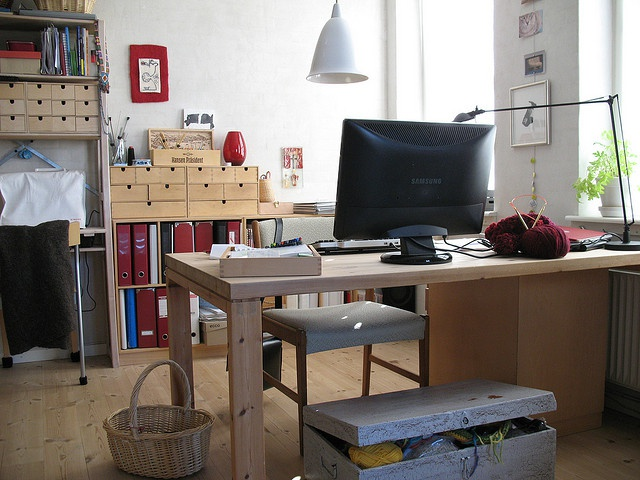Describe the objects in this image and their specific colors. I can see tv in black, gray, and darkblue tones, chair in black, gray, darkgray, and tan tones, book in black, maroon, gray, and darkgray tones, potted plant in black, ivory, darkgray, lightgreen, and olive tones, and keyboard in black, darkgray, gray, and lightgray tones in this image. 